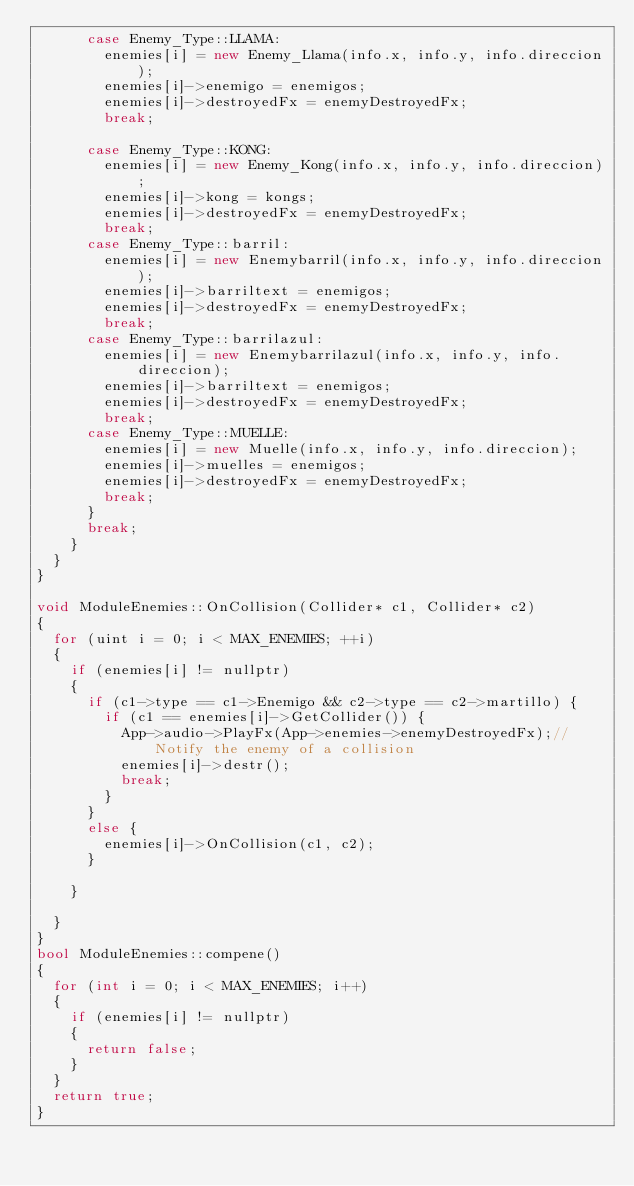<code> <loc_0><loc_0><loc_500><loc_500><_C++_>			case Enemy_Type::LLAMA:
				enemies[i] = new Enemy_Llama(info.x, info.y, info.direccion);
				enemies[i]->enemigo = enemigos;
				enemies[i]->destroyedFx = enemyDestroyedFx;
				break;

			case Enemy_Type::KONG:
				enemies[i] = new Enemy_Kong(info.x, info.y, info.direccion);
				enemies[i]->kong = kongs;
				enemies[i]->destroyedFx = enemyDestroyedFx;
				break;
			case Enemy_Type::barril:
				enemies[i] = new Enemybarril(info.x, info.y, info.direccion);
				enemies[i]->barriltext = enemigos;
				enemies[i]->destroyedFx = enemyDestroyedFx;
				break;
			case Enemy_Type::barrilazul:
				enemies[i] = new Enemybarrilazul(info.x, info.y, info.direccion);
				enemies[i]->barriltext = enemigos;
				enemies[i]->destroyedFx = enemyDestroyedFx;
				break;
			case Enemy_Type::MUELLE:
				enemies[i] = new Muelle(info.x, info.y, info.direccion);
				enemies[i]->muelles = enemigos;
				enemies[i]->destroyedFx = enemyDestroyedFx;
				break;
			}
			break;
		}
	}
}

void ModuleEnemies::OnCollision(Collider* c1, Collider* c2)
{
	for (uint i = 0; i < MAX_ENEMIES; ++i)
	{
		if (enemies[i] != nullptr)
		{
			if (c1->type == c1->Enemigo && c2->type == c2->martillo) {
				if (c1 == enemies[i]->GetCollider()) {
					App->audio->PlayFx(App->enemies->enemyDestroyedFx);//Notify the enemy of a collision
					enemies[i]->destr();
					break;
				}	
			}
			else {
				enemies[i]->OnCollision(c1, c2);
			}

		}

	}
}
bool ModuleEnemies::compene()
{
	for (int i = 0; i < MAX_ENEMIES; i++) 
	{
		if (enemies[i] != nullptr) 
		{
			return false;
		}
	}
	return true;
}</code> 